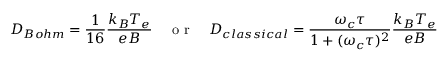<formula> <loc_0><loc_0><loc_500><loc_500>D _ { B o h m } = \frac { 1 } { 1 6 } \frac { k _ { B } T _ { e } } { e B } \quad o r \quad D _ { c l a s s i c a l } = \frac { \omega _ { c } \tau } { 1 + ( \omega _ { c } \tau ) ^ { 2 } } \frac { k _ { B } T _ { e } } { e B }</formula> 